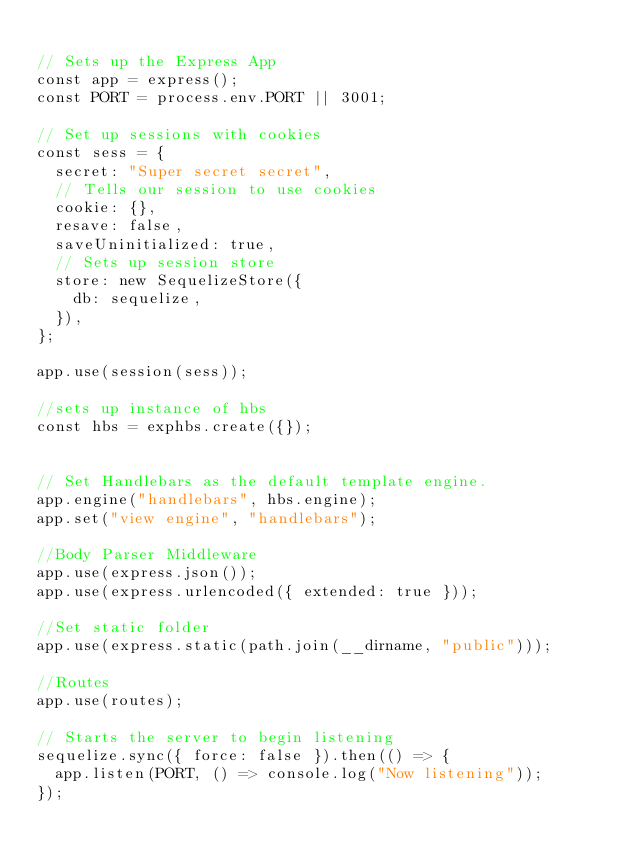<code> <loc_0><loc_0><loc_500><loc_500><_JavaScript_>
// Sets up the Express App
const app = express();
const PORT = process.env.PORT || 3001;

// Set up sessions with cookies
const sess = {
  secret: "Super secret secret",
  // Tells our session to use cookies
  cookie: {},
  resave: false,
  saveUninitialized: true,
  // Sets up session store
  store: new SequelizeStore({
    db: sequelize,
  }),
};

app.use(session(sess));

//sets up instance of hbs
const hbs = exphbs.create({});


// Set Handlebars as the default template engine.
app.engine("handlebars", hbs.engine);
app.set("view engine", "handlebars");

//Body Parser Middleware
app.use(express.json());
app.use(express.urlencoded({ extended: true }));

//Set static folder
app.use(express.static(path.join(__dirname, "public")));

//Routes
app.use(routes);

// Starts the server to begin listening
sequelize.sync({ force: false }).then(() => {
  app.listen(PORT, () => console.log("Now listening"));
});
</code> 